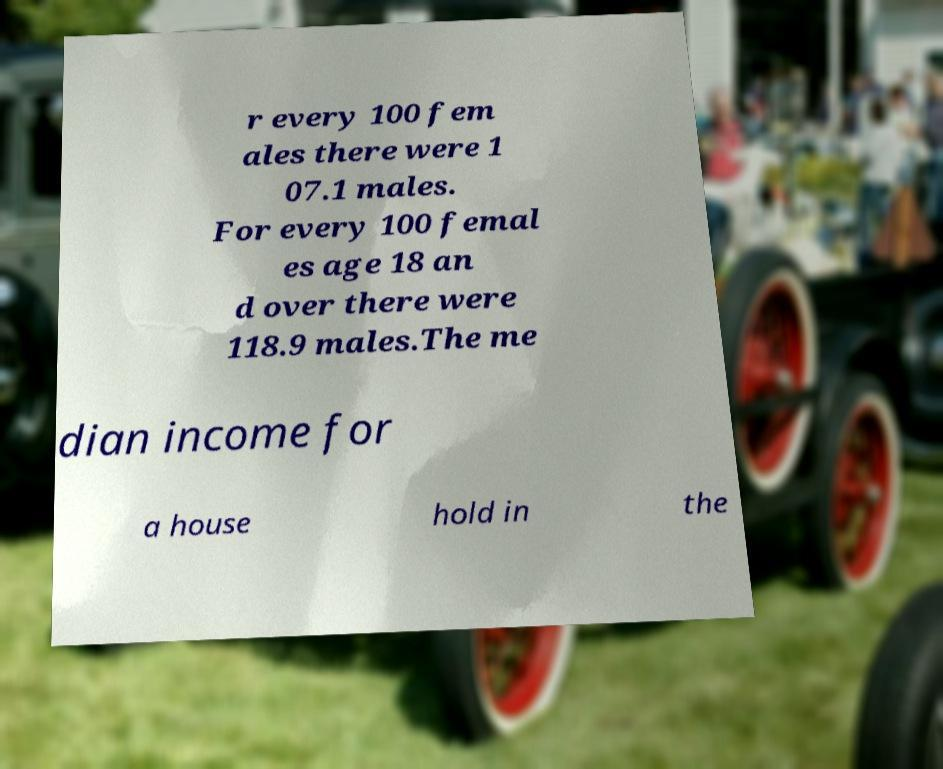What messages or text are displayed in this image? I need them in a readable, typed format. r every 100 fem ales there were 1 07.1 males. For every 100 femal es age 18 an d over there were 118.9 males.The me dian income for a house hold in the 